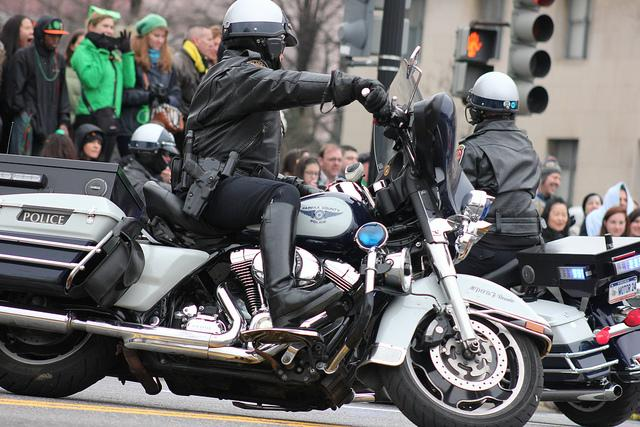Ignoring everything else about the image what should pedestrians do about crossing the street according to the traffic light? stop 